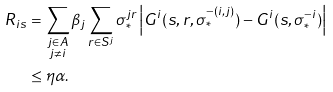Convert formula to latex. <formula><loc_0><loc_0><loc_500><loc_500>R _ { i s } & = \sum _ { \substack { j \in A \\ j \neq i } } \beta _ { j } \sum _ { r \in S ^ { j } } \sigma _ { * } ^ { j r } \left | G ^ { i } ( s , r , \sigma _ { * } ^ { - ( i , j ) } ) - G ^ { i } ( s , \sigma _ { * } ^ { - i } ) \right | \\ & \leq \eta \alpha .</formula> 